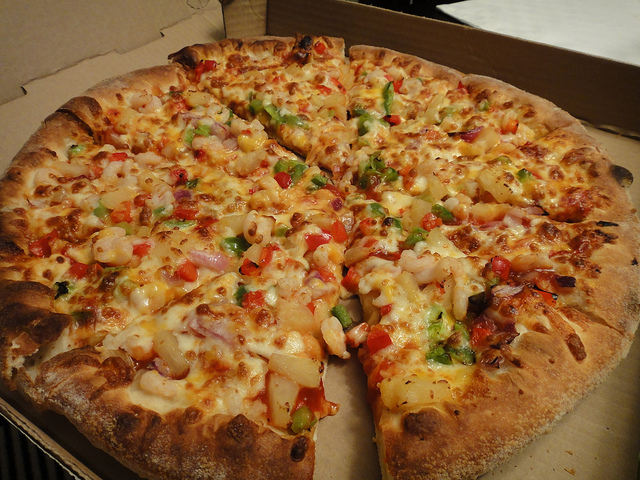<image>What color sauce is on the pizza? I don't know what color the sauce on the pizza is. It could be yellow, white, or red. What color sauce is on the pizza? There is red sauce on the pizza. 